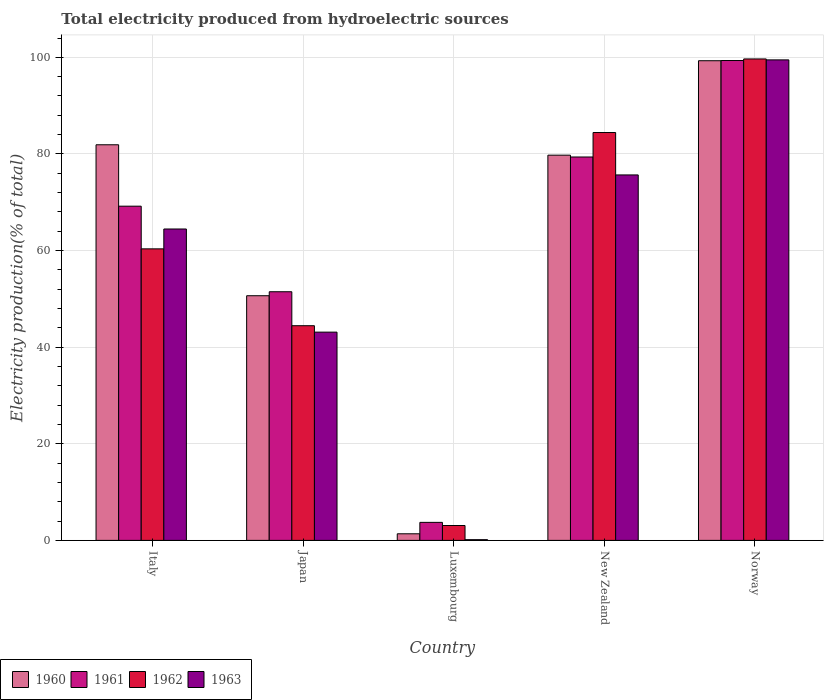How many different coloured bars are there?
Your answer should be very brief. 4. How many groups of bars are there?
Give a very brief answer. 5. Are the number of bars per tick equal to the number of legend labels?
Keep it short and to the point. Yes. How many bars are there on the 5th tick from the right?
Your response must be concise. 4. What is the label of the 2nd group of bars from the left?
Give a very brief answer. Japan. What is the total electricity produced in 1963 in Japan?
Provide a succinct answer. 43.11. Across all countries, what is the maximum total electricity produced in 1963?
Offer a terse response. 99.47. Across all countries, what is the minimum total electricity produced in 1961?
Provide a succinct answer. 3.73. In which country was the total electricity produced in 1960 minimum?
Give a very brief answer. Luxembourg. What is the total total electricity produced in 1961 in the graph?
Keep it short and to the point. 303.11. What is the difference between the total electricity produced in 1963 in Japan and that in Luxembourg?
Provide a succinct answer. 42.97. What is the difference between the total electricity produced in 1963 in New Zealand and the total electricity produced in 1960 in Italy?
Provide a succinct answer. -6.24. What is the average total electricity produced in 1963 per country?
Your answer should be very brief. 56.57. What is the difference between the total electricity produced of/in 1960 and total electricity produced of/in 1962 in Japan?
Give a very brief answer. 6.2. In how many countries, is the total electricity produced in 1960 greater than 16 %?
Ensure brevity in your answer.  4. What is the ratio of the total electricity produced in 1963 in Japan to that in New Zealand?
Your response must be concise. 0.57. Is the total electricity produced in 1963 in Italy less than that in Japan?
Give a very brief answer. No. Is the difference between the total electricity produced in 1960 in Italy and Norway greater than the difference between the total electricity produced in 1962 in Italy and Norway?
Ensure brevity in your answer.  Yes. What is the difference between the highest and the second highest total electricity produced in 1961?
Offer a terse response. 30.15. What is the difference between the highest and the lowest total electricity produced in 1962?
Your answer should be compact. 96.59. Is it the case that in every country, the sum of the total electricity produced in 1962 and total electricity produced in 1961 is greater than the sum of total electricity produced in 1960 and total electricity produced in 1963?
Provide a succinct answer. No. How many bars are there?
Your response must be concise. 20. Are all the bars in the graph horizontal?
Keep it short and to the point. No. What is the difference between two consecutive major ticks on the Y-axis?
Give a very brief answer. 20. Does the graph contain any zero values?
Your response must be concise. No. Where does the legend appear in the graph?
Provide a short and direct response. Bottom left. How many legend labels are there?
Your answer should be compact. 4. How are the legend labels stacked?
Keep it short and to the point. Horizontal. What is the title of the graph?
Keep it short and to the point. Total electricity produced from hydroelectric sources. Does "1983" appear as one of the legend labels in the graph?
Your response must be concise. No. What is the label or title of the X-axis?
Offer a terse response. Country. What is the label or title of the Y-axis?
Provide a short and direct response. Electricity production(% of total). What is the Electricity production(% of total) of 1960 in Italy?
Your answer should be very brief. 81.9. What is the Electricity production(% of total) of 1961 in Italy?
Your answer should be compact. 69.19. What is the Electricity production(% of total) of 1962 in Italy?
Keep it short and to the point. 60.35. What is the Electricity production(% of total) in 1963 in Italy?
Your answer should be compact. 64.47. What is the Electricity production(% of total) in 1960 in Japan?
Make the answer very short. 50.65. What is the Electricity production(% of total) in 1961 in Japan?
Offer a very short reply. 51.48. What is the Electricity production(% of total) in 1962 in Japan?
Provide a succinct answer. 44.44. What is the Electricity production(% of total) in 1963 in Japan?
Give a very brief answer. 43.11. What is the Electricity production(% of total) of 1960 in Luxembourg?
Offer a terse response. 1.37. What is the Electricity production(% of total) of 1961 in Luxembourg?
Your answer should be compact. 3.73. What is the Electricity production(% of total) of 1962 in Luxembourg?
Your answer should be very brief. 3.08. What is the Electricity production(% of total) of 1963 in Luxembourg?
Provide a succinct answer. 0.15. What is the Electricity production(% of total) of 1960 in New Zealand?
Give a very brief answer. 79.75. What is the Electricity production(% of total) in 1961 in New Zealand?
Give a very brief answer. 79.37. What is the Electricity production(% of total) of 1962 in New Zealand?
Keep it short and to the point. 84.44. What is the Electricity production(% of total) of 1963 in New Zealand?
Keep it short and to the point. 75.66. What is the Electricity production(% of total) of 1960 in Norway?
Keep it short and to the point. 99.3. What is the Electricity production(% of total) of 1961 in Norway?
Make the answer very short. 99.34. What is the Electricity production(% of total) in 1962 in Norway?
Offer a terse response. 99.67. What is the Electricity production(% of total) in 1963 in Norway?
Offer a terse response. 99.47. Across all countries, what is the maximum Electricity production(% of total) of 1960?
Your response must be concise. 99.3. Across all countries, what is the maximum Electricity production(% of total) of 1961?
Give a very brief answer. 99.34. Across all countries, what is the maximum Electricity production(% of total) of 1962?
Offer a very short reply. 99.67. Across all countries, what is the maximum Electricity production(% of total) of 1963?
Keep it short and to the point. 99.47. Across all countries, what is the minimum Electricity production(% of total) of 1960?
Your response must be concise. 1.37. Across all countries, what is the minimum Electricity production(% of total) in 1961?
Make the answer very short. 3.73. Across all countries, what is the minimum Electricity production(% of total) in 1962?
Your response must be concise. 3.08. Across all countries, what is the minimum Electricity production(% of total) of 1963?
Provide a succinct answer. 0.15. What is the total Electricity production(% of total) in 1960 in the graph?
Provide a succinct answer. 312.97. What is the total Electricity production(% of total) in 1961 in the graph?
Your answer should be compact. 303.11. What is the total Electricity production(% of total) in 1962 in the graph?
Keep it short and to the point. 291.99. What is the total Electricity production(% of total) of 1963 in the graph?
Offer a terse response. 282.86. What is the difference between the Electricity production(% of total) in 1960 in Italy and that in Japan?
Ensure brevity in your answer.  31.25. What is the difference between the Electricity production(% of total) of 1961 in Italy and that in Japan?
Offer a very short reply. 17.71. What is the difference between the Electricity production(% of total) in 1962 in Italy and that in Japan?
Your answer should be very brief. 15.91. What is the difference between the Electricity production(% of total) in 1963 in Italy and that in Japan?
Your response must be concise. 21.35. What is the difference between the Electricity production(% of total) in 1960 in Italy and that in Luxembourg?
Offer a very short reply. 80.53. What is the difference between the Electricity production(% of total) of 1961 in Italy and that in Luxembourg?
Offer a terse response. 65.46. What is the difference between the Electricity production(% of total) of 1962 in Italy and that in Luxembourg?
Give a very brief answer. 57.27. What is the difference between the Electricity production(% of total) in 1963 in Italy and that in Luxembourg?
Provide a short and direct response. 64.32. What is the difference between the Electricity production(% of total) of 1960 in Italy and that in New Zealand?
Your answer should be compact. 2.15. What is the difference between the Electricity production(% of total) in 1961 in Italy and that in New Zealand?
Provide a succinct answer. -10.18. What is the difference between the Electricity production(% of total) in 1962 in Italy and that in New Zealand?
Ensure brevity in your answer.  -24.08. What is the difference between the Electricity production(% of total) of 1963 in Italy and that in New Zealand?
Your answer should be very brief. -11.19. What is the difference between the Electricity production(% of total) of 1960 in Italy and that in Norway?
Make the answer very short. -17.4. What is the difference between the Electricity production(% of total) in 1961 in Italy and that in Norway?
Ensure brevity in your answer.  -30.15. What is the difference between the Electricity production(% of total) in 1962 in Italy and that in Norway?
Offer a terse response. -39.32. What is the difference between the Electricity production(% of total) in 1963 in Italy and that in Norway?
Your answer should be very brief. -35.01. What is the difference between the Electricity production(% of total) of 1960 in Japan and that in Luxembourg?
Provide a succinct answer. 49.28. What is the difference between the Electricity production(% of total) of 1961 in Japan and that in Luxembourg?
Provide a succinct answer. 47.75. What is the difference between the Electricity production(% of total) in 1962 in Japan and that in Luxembourg?
Provide a succinct answer. 41.36. What is the difference between the Electricity production(% of total) of 1963 in Japan and that in Luxembourg?
Your answer should be very brief. 42.97. What is the difference between the Electricity production(% of total) in 1960 in Japan and that in New Zealand?
Give a very brief answer. -29.1. What is the difference between the Electricity production(% of total) in 1961 in Japan and that in New Zealand?
Your answer should be compact. -27.9. What is the difference between the Electricity production(% of total) of 1962 in Japan and that in New Zealand?
Provide a succinct answer. -39.99. What is the difference between the Electricity production(% of total) in 1963 in Japan and that in New Zealand?
Make the answer very short. -32.54. What is the difference between the Electricity production(% of total) of 1960 in Japan and that in Norway?
Provide a succinct answer. -48.65. What is the difference between the Electricity production(% of total) in 1961 in Japan and that in Norway?
Make the answer very short. -47.87. What is the difference between the Electricity production(% of total) in 1962 in Japan and that in Norway?
Your response must be concise. -55.23. What is the difference between the Electricity production(% of total) of 1963 in Japan and that in Norway?
Keep it short and to the point. -56.36. What is the difference between the Electricity production(% of total) of 1960 in Luxembourg and that in New Zealand?
Offer a very short reply. -78.38. What is the difference between the Electricity production(% of total) in 1961 in Luxembourg and that in New Zealand?
Give a very brief answer. -75.64. What is the difference between the Electricity production(% of total) in 1962 in Luxembourg and that in New Zealand?
Make the answer very short. -81.36. What is the difference between the Electricity production(% of total) in 1963 in Luxembourg and that in New Zealand?
Your response must be concise. -75.51. What is the difference between the Electricity production(% of total) of 1960 in Luxembourg and that in Norway?
Provide a short and direct response. -97.93. What is the difference between the Electricity production(% of total) of 1961 in Luxembourg and that in Norway?
Give a very brief answer. -95.61. What is the difference between the Electricity production(% of total) of 1962 in Luxembourg and that in Norway?
Make the answer very short. -96.59. What is the difference between the Electricity production(% of total) of 1963 in Luxembourg and that in Norway?
Provide a succinct answer. -99.33. What is the difference between the Electricity production(% of total) of 1960 in New Zealand and that in Norway?
Your response must be concise. -19.55. What is the difference between the Electricity production(% of total) of 1961 in New Zealand and that in Norway?
Offer a terse response. -19.97. What is the difference between the Electricity production(% of total) in 1962 in New Zealand and that in Norway?
Give a very brief answer. -15.23. What is the difference between the Electricity production(% of total) in 1963 in New Zealand and that in Norway?
Your answer should be compact. -23.82. What is the difference between the Electricity production(% of total) of 1960 in Italy and the Electricity production(% of total) of 1961 in Japan?
Ensure brevity in your answer.  30.42. What is the difference between the Electricity production(% of total) in 1960 in Italy and the Electricity production(% of total) in 1962 in Japan?
Your response must be concise. 37.46. What is the difference between the Electricity production(% of total) in 1960 in Italy and the Electricity production(% of total) in 1963 in Japan?
Make the answer very short. 38.79. What is the difference between the Electricity production(% of total) in 1961 in Italy and the Electricity production(% of total) in 1962 in Japan?
Offer a very short reply. 24.75. What is the difference between the Electricity production(% of total) of 1961 in Italy and the Electricity production(% of total) of 1963 in Japan?
Give a very brief answer. 26.08. What is the difference between the Electricity production(% of total) of 1962 in Italy and the Electricity production(% of total) of 1963 in Japan?
Keep it short and to the point. 17.24. What is the difference between the Electricity production(% of total) in 1960 in Italy and the Electricity production(% of total) in 1961 in Luxembourg?
Make the answer very short. 78.17. What is the difference between the Electricity production(% of total) in 1960 in Italy and the Electricity production(% of total) in 1962 in Luxembourg?
Provide a succinct answer. 78.82. What is the difference between the Electricity production(% of total) of 1960 in Italy and the Electricity production(% of total) of 1963 in Luxembourg?
Offer a very short reply. 81.75. What is the difference between the Electricity production(% of total) in 1961 in Italy and the Electricity production(% of total) in 1962 in Luxembourg?
Provide a short and direct response. 66.11. What is the difference between the Electricity production(% of total) in 1961 in Italy and the Electricity production(% of total) in 1963 in Luxembourg?
Keep it short and to the point. 69.04. What is the difference between the Electricity production(% of total) in 1962 in Italy and the Electricity production(% of total) in 1963 in Luxembourg?
Provide a short and direct response. 60.21. What is the difference between the Electricity production(% of total) in 1960 in Italy and the Electricity production(% of total) in 1961 in New Zealand?
Your answer should be very brief. 2.53. What is the difference between the Electricity production(% of total) of 1960 in Italy and the Electricity production(% of total) of 1962 in New Zealand?
Your answer should be very brief. -2.54. What is the difference between the Electricity production(% of total) of 1960 in Italy and the Electricity production(% of total) of 1963 in New Zealand?
Ensure brevity in your answer.  6.24. What is the difference between the Electricity production(% of total) of 1961 in Italy and the Electricity production(% of total) of 1962 in New Zealand?
Your answer should be compact. -15.25. What is the difference between the Electricity production(% of total) of 1961 in Italy and the Electricity production(% of total) of 1963 in New Zealand?
Your answer should be compact. -6.47. What is the difference between the Electricity production(% of total) in 1962 in Italy and the Electricity production(% of total) in 1963 in New Zealand?
Provide a short and direct response. -15.3. What is the difference between the Electricity production(% of total) of 1960 in Italy and the Electricity production(% of total) of 1961 in Norway?
Offer a very short reply. -17.44. What is the difference between the Electricity production(% of total) of 1960 in Italy and the Electricity production(% of total) of 1962 in Norway?
Ensure brevity in your answer.  -17.77. What is the difference between the Electricity production(% of total) in 1960 in Italy and the Electricity production(% of total) in 1963 in Norway?
Provide a succinct answer. -17.57. What is the difference between the Electricity production(% of total) in 1961 in Italy and the Electricity production(% of total) in 1962 in Norway?
Offer a very short reply. -30.48. What is the difference between the Electricity production(% of total) in 1961 in Italy and the Electricity production(% of total) in 1963 in Norway?
Make the answer very short. -30.28. What is the difference between the Electricity production(% of total) in 1962 in Italy and the Electricity production(% of total) in 1963 in Norway?
Provide a succinct answer. -39.12. What is the difference between the Electricity production(% of total) of 1960 in Japan and the Electricity production(% of total) of 1961 in Luxembourg?
Provide a succinct answer. 46.92. What is the difference between the Electricity production(% of total) in 1960 in Japan and the Electricity production(% of total) in 1962 in Luxembourg?
Make the answer very short. 47.57. What is the difference between the Electricity production(% of total) in 1960 in Japan and the Electricity production(% of total) in 1963 in Luxembourg?
Your answer should be compact. 50.5. What is the difference between the Electricity production(% of total) of 1961 in Japan and the Electricity production(% of total) of 1962 in Luxembourg?
Offer a very short reply. 48.39. What is the difference between the Electricity production(% of total) in 1961 in Japan and the Electricity production(% of total) in 1963 in Luxembourg?
Give a very brief answer. 51.33. What is the difference between the Electricity production(% of total) of 1962 in Japan and the Electricity production(% of total) of 1963 in Luxembourg?
Your answer should be compact. 44.3. What is the difference between the Electricity production(% of total) of 1960 in Japan and the Electricity production(% of total) of 1961 in New Zealand?
Your answer should be compact. -28.72. What is the difference between the Electricity production(% of total) of 1960 in Japan and the Electricity production(% of total) of 1962 in New Zealand?
Give a very brief answer. -33.79. What is the difference between the Electricity production(% of total) of 1960 in Japan and the Electricity production(% of total) of 1963 in New Zealand?
Ensure brevity in your answer.  -25.01. What is the difference between the Electricity production(% of total) in 1961 in Japan and the Electricity production(% of total) in 1962 in New Zealand?
Keep it short and to the point. -32.96. What is the difference between the Electricity production(% of total) of 1961 in Japan and the Electricity production(% of total) of 1963 in New Zealand?
Your answer should be very brief. -24.18. What is the difference between the Electricity production(% of total) in 1962 in Japan and the Electricity production(% of total) in 1963 in New Zealand?
Provide a succinct answer. -31.21. What is the difference between the Electricity production(% of total) of 1960 in Japan and the Electricity production(% of total) of 1961 in Norway?
Provide a short and direct response. -48.69. What is the difference between the Electricity production(% of total) in 1960 in Japan and the Electricity production(% of total) in 1962 in Norway?
Your answer should be very brief. -49.02. What is the difference between the Electricity production(% of total) of 1960 in Japan and the Electricity production(% of total) of 1963 in Norway?
Your answer should be compact. -48.83. What is the difference between the Electricity production(% of total) of 1961 in Japan and the Electricity production(% of total) of 1962 in Norway?
Give a very brief answer. -48.19. What is the difference between the Electricity production(% of total) in 1961 in Japan and the Electricity production(% of total) in 1963 in Norway?
Keep it short and to the point. -48. What is the difference between the Electricity production(% of total) in 1962 in Japan and the Electricity production(% of total) in 1963 in Norway?
Give a very brief answer. -55.03. What is the difference between the Electricity production(% of total) in 1960 in Luxembourg and the Electricity production(% of total) in 1961 in New Zealand?
Provide a short and direct response. -78.01. What is the difference between the Electricity production(% of total) in 1960 in Luxembourg and the Electricity production(% of total) in 1962 in New Zealand?
Keep it short and to the point. -83.07. What is the difference between the Electricity production(% of total) of 1960 in Luxembourg and the Electricity production(% of total) of 1963 in New Zealand?
Your response must be concise. -74.29. What is the difference between the Electricity production(% of total) in 1961 in Luxembourg and the Electricity production(% of total) in 1962 in New Zealand?
Ensure brevity in your answer.  -80.71. What is the difference between the Electricity production(% of total) in 1961 in Luxembourg and the Electricity production(% of total) in 1963 in New Zealand?
Your answer should be compact. -71.93. What is the difference between the Electricity production(% of total) in 1962 in Luxembourg and the Electricity production(% of total) in 1963 in New Zealand?
Make the answer very short. -72.58. What is the difference between the Electricity production(% of total) in 1960 in Luxembourg and the Electricity production(% of total) in 1961 in Norway?
Ensure brevity in your answer.  -97.98. What is the difference between the Electricity production(% of total) in 1960 in Luxembourg and the Electricity production(% of total) in 1962 in Norway?
Make the answer very short. -98.3. What is the difference between the Electricity production(% of total) in 1960 in Luxembourg and the Electricity production(% of total) in 1963 in Norway?
Keep it short and to the point. -98.11. What is the difference between the Electricity production(% of total) of 1961 in Luxembourg and the Electricity production(% of total) of 1962 in Norway?
Provide a short and direct response. -95.94. What is the difference between the Electricity production(% of total) in 1961 in Luxembourg and the Electricity production(% of total) in 1963 in Norway?
Your response must be concise. -95.74. What is the difference between the Electricity production(% of total) in 1962 in Luxembourg and the Electricity production(% of total) in 1963 in Norway?
Your answer should be compact. -96.39. What is the difference between the Electricity production(% of total) of 1960 in New Zealand and the Electricity production(% of total) of 1961 in Norway?
Your answer should be compact. -19.59. What is the difference between the Electricity production(% of total) in 1960 in New Zealand and the Electricity production(% of total) in 1962 in Norway?
Offer a terse response. -19.92. What is the difference between the Electricity production(% of total) in 1960 in New Zealand and the Electricity production(% of total) in 1963 in Norway?
Ensure brevity in your answer.  -19.72. What is the difference between the Electricity production(% of total) in 1961 in New Zealand and the Electricity production(% of total) in 1962 in Norway?
Your response must be concise. -20.3. What is the difference between the Electricity production(% of total) in 1961 in New Zealand and the Electricity production(% of total) in 1963 in Norway?
Give a very brief answer. -20.1. What is the difference between the Electricity production(% of total) in 1962 in New Zealand and the Electricity production(% of total) in 1963 in Norway?
Give a very brief answer. -15.04. What is the average Electricity production(% of total) of 1960 per country?
Your answer should be very brief. 62.59. What is the average Electricity production(% of total) of 1961 per country?
Make the answer very short. 60.62. What is the average Electricity production(% of total) of 1962 per country?
Provide a succinct answer. 58.4. What is the average Electricity production(% of total) of 1963 per country?
Your answer should be compact. 56.57. What is the difference between the Electricity production(% of total) in 1960 and Electricity production(% of total) in 1961 in Italy?
Offer a terse response. 12.71. What is the difference between the Electricity production(% of total) in 1960 and Electricity production(% of total) in 1962 in Italy?
Your answer should be compact. 21.55. What is the difference between the Electricity production(% of total) in 1960 and Electricity production(% of total) in 1963 in Italy?
Offer a very short reply. 17.43. What is the difference between the Electricity production(% of total) of 1961 and Electricity production(% of total) of 1962 in Italy?
Offer a terse response. 8.84. What is the difference between the Electricity production(% of total) of 1961 and Electricity production(% of total) of 1963 in Italy?
Offer a very short reply. 4.72. What is the difference between the Electricity production(% of total) of 1962 and Electricity production(% of total) of 1963 in Italy?
Your answer should be compact. -4.11. What is the difference between the Electricity production(% of total) in 1960 and Electricity production(% of total) in 1961 in Japan?
Your answer should be very brief. -0.83. What is the difference between the Electricity production(% of total) of 1960 and Electricity production(% of total) of 1962 in Japan?
Provide a succinct answer. 6.2. What is the difference between the Electricity production(% of total) in 1960 and Electricity production(% of total) in 1963 in Japan?
Provide a succinct answer. 7.54. What is the difference between the Electricity production(% of total) of 1961 and Electricity production(% of total) of 1962 in Japan?
Your answer should be very brief. 7.03. What is the difference between the Electricity production(% of total) of 1961 and Electricity production(% of total) of 1963 in Japan?
Your answer should be very brief. 8.36. What is the difference between the Electricity production(% of total) in 1962 and Electricity production(% of total) in 1963 in Japan?
Offer a terse response. 1.33. What is the difference between the Electricity production(% of total) of 1960 and Electricity production(% of total) of 1961 in Luxembourg?
Your answer should be very brief. -2.36. What is the difference between the Electricity production(% of total) in 1960 and Electricity production(% of total) in 1962 in Luxembourg?
Offer a terse response. -1.72. What is the difference between the Electricity production(% of total) of 1960 and Electricity production(% of total) of 1963 in Luxembourg?
Your response must be concise. 1.22. What is the difference between the Electricity production(% of total) of 1961 and Electricity production(% of total) of 1962 in Luxembourg?
Keep it short and to the point. 0.65. What is the difference between the Electricity production(% of total) of 1961 and Electricity production(% of total) of 1963 in Luxembourg?
Offer a very short reply. 3.58. What is the difference between the Electricity production(% of total) of 1962 and Electricity production(% of total) of 1963 in Luxembourg?
Keep it short and to the point. 2.93. What is the difference between the Electricity production(% of total) of 1960 and Electricity production(% of total) of 1961 in New Zealand?
Your answer should be compact. 0.38. What is the difference between the Electricity production(% of total) in 1960 and Electricity production(% of total) in 1962 in New Zealand?
Make the answer very short. -4.69. What is the difference between the Electricity production(% of total) of 1960 and Electricity production(% of total) of 1963 in New Zealand?
Give a very brief answer. 4.09. What is the difference between the Electricity production(% of total) of 1961 and Electricity production(% of total) of 1962 in New Zealand?
Your answer should be very brief. -5.07. What is the difference between the Electricity production(% of total) in 1961 and Electricity production(% of total) in 1963 in New Zealand?
Offer a very short reply. 3.71. What is the difference between the Electricity production(% of total) of 1962 and Electricity production(% of total) of 1963 in New Zealand?
Keep it short and to the point. 8.78. What is the difference between the Electricity production(% of total) of 1960 and Electricity production(% of total) of 1961 in Norway?
Make the answer very short. -0.04. What is the difference between the Electricity production(% of total) in 1960 and Electricity production(% of total) in 1962 in Norway?
Offer a terse response. -0.37. What is the difference between the Electricity production(% of total) in 1960 and Electricity production(% of total) in 1963 in Norway?
Provide a succinct answer. -0.17. What is the difference between the Electricity production(% of total) of 1961 and Electricity production(% of total) of 1962 in Norway?
Make the answer very short. -0.33. What is the difference between the Electricity production(% of total) of 1961 and Electricity production(% of total) of 1963 in Norway?
Keep it short and to the point. -0.13. What is the difference between the Electricity production(% of total) of 1962 and Electricity production(% of total) of 1963 in Norway?
Your response must be concise. 0.19. What is the ratio of the Electricity production(% of total) of 1960 in Italy to that in Japan?
Keep it short and to the point. 1.62. What is the ratio of the Electricity production(% of total) in 1961 in Italy to that in Japan?
Ensure brevity in your answer.  1.34. What is the ratio of the Electricity production(% of total) in 1962 in Italy to that in Japan?
Provide a succinct answer. 1.36. What is the ratio of the Electricity production(% of total) of 1963 in Italy to that in Japan?
Your response must be concise. 1.5. What is the ratio of the Electricity production(% of total) in 1960 in Italy to that in Luxembourg?
Give a very brief answer. 59.95. What is the ratio of the Electricity production(% of total) in 1961 in Italy to that in Luxembourg?
Your answer should be compact. 18.55. What is the ratio of the Electricity production(% of total) of 1962 in Italy to that in Luxembourg?
Ensure brevity in your answer.  19.58. What is the ratio of the Electricity production(% of total) of 1963 in Italy to that in Luxembourg?
Offer a very short reply. 436.77. What is the ratio of the Electricity production(% of total) of 1960 in Italy to that in New Zealand?
Your answer should be compact. 1.03. What is the ratio of the Electricity production(% of total) of 1961 in Italy to that in New Zealand?
Provide a succinct answer. 0.87. What is the ratio of the Electricity production(% of total) of 1962 in Italy to that in New Zealand?
Ensure brevity in your answer.  0.71. What is the ratio of the Electricity production(% of total) of 1963 in Italy to that in New Zealand?
Your answer should be very brief. 0.85. What is the ratio of the Electricity production(% of total) in 1960 in Italy to that in Norway?
Offer a very short reply. 0.82. What is the ratio of the Electricity production(% of total) in 1961 in Italy to that in Norway?
Offer a terse response. 0.7. What is the ratio of the Electricity production(% of total) of 1962 in Italy to that in Norway?
Your answer should be compact. 0.61. What is the ratio of the Electricity production(% of total) in 1963 in Italy to that in Norway?
Give a very brief answer. 0.65. What is the ratio of the Electricity production(% of total) of 1960 in Japan to that in Luxembourg?
Provide a succinct answer. 37.08. What is the ratio of the Electricity production(% of total) in 1961 in Japan to that in Luxembourg?
Ensure brevity in your answer.  13.8. What is the ratio of the Electricity production(% of total) of 1962 in Japan to that in Luxembourg?
Your response must be concise. 14.42. What is the ratio of the Electricity production(% of total) in 1963 in Japan to that in Luxembourg?
Provide a short and direct response. 292.1. What is the ratio of the Electricity production(% of total) in 1960 in Japan to that in New Zealand?
Provide a succinct answer. 0.64. What is the ratio of the Electricity production(% of total) in 1961 in Japan to that in New Zealand?
Keep it short and to the point. 0.65. What is the ratio of the Electricity production(% of total) in 1962 in Japan to that in New Zealand?
Offer a very short reply. 0.53. What is the ratio of the Electricity production(% of total) of 1963 in Japan to that in New Zealand?
Give a very brief answer. 0.57. What is the ratio of the Electricity production(% of total) in 1960 in Japan to that in Norway?
Your answer should be compact. 0.51. What is the ratio of the Electricity production(% of total) of 1961 in Japan to that in Norway?
Make the answer very short. 0.52. What is the ratio of the Electricity production(% of total) in 1962 in Japan to that in Norway?
Offer a very short reply. 0.45. What is the ratio of the Electricity production(% of total) of 1963 in Japan to that in Norway?
Make the answer very short. 0.43. What is the ratio of the Electricity production(% of total) in 1960 in Luxembourg to that in New Zealand?
Make the answer very short. 0.02. What is the ratio of the Electricity production(% of total) in 1961 in Luxembourg to that in New Zealand?
Keep it short and to the point. 0.05. What is the ratio of the Electricity production(% of total) in 1962 in Luxembourg to that in New Zealand?
Make the answer very short. 0.04. What is the ratio of the Electricity production(% of total) of 1963 in Luxembourg to that in New Zealand?
Provide a succinct answer. 0. What is the ratio of the Electricity production(% of total) in 1960 in Luxembourg to that in Norway?
Your answer should be compact. 0.01. What is the ratio of the Electricity production(% of total) in 1961 in Luxembourg to that in Norway?
Provide a short and direct response. 0.04. What is the ratio of the Electricity production(% of total) in 1962 in Luxembourg to that in Norway?
Your answer should be compact. 0.03. What is the ratio of the Electricity production(% of total) of 1963 in Luxembourg to that in Norway?
Give a very brief answer. 0. What is the ratio of the Electricity production(% of total) in 1960 in New Zealand to that in Norway?
Give a very brief answer. 0.8. What is the ratio of the Electricity production(% of total) of 1961 in New Zealand to that in Norway?
Offer a terse response. 0.8. What is the ratio of the Electricity production(% of total) in 1962 in New Zealand to that in Norway?
Your answer should be compact. 0.85. What is the ratio of the Electricity production(% of total) in 1963 in New Zealand to that in Norway?
Your response must be concise. 0.76. What is the difference between the highest and the second highest Electricity production(% of total) in 1960?
Provide a short and direct response. 17.4. What is the difference between the highest and the second highest Electricity production(% of total) in 1961?
Provide a succinct answer. 19.97. What is the difference between the highest and the second highest Electricity production(% of total) of 1962?
Your answer should be compact. 15.23. What is the difference between the highest and the second highest Electricity production(% of total) of 1963?
Keep it short and to the point. 23.82. What is the difference between the highest and the lowest Electricity production(% of total) of 1960?
Make the answer very short. 97.93. What is the difference between the highest and the lowest Electricity production(% of total) of 1961?
Keep it short and to the point. 95.61. What is the difference between the highest and the lowest Electricity production(% of total) of 1962?
Ensure brevity in your answer.  96.59. What is the difference between the highest and the lowest Electricity production(% of total) in 1963?
Your answer should be compact. 99.33. 